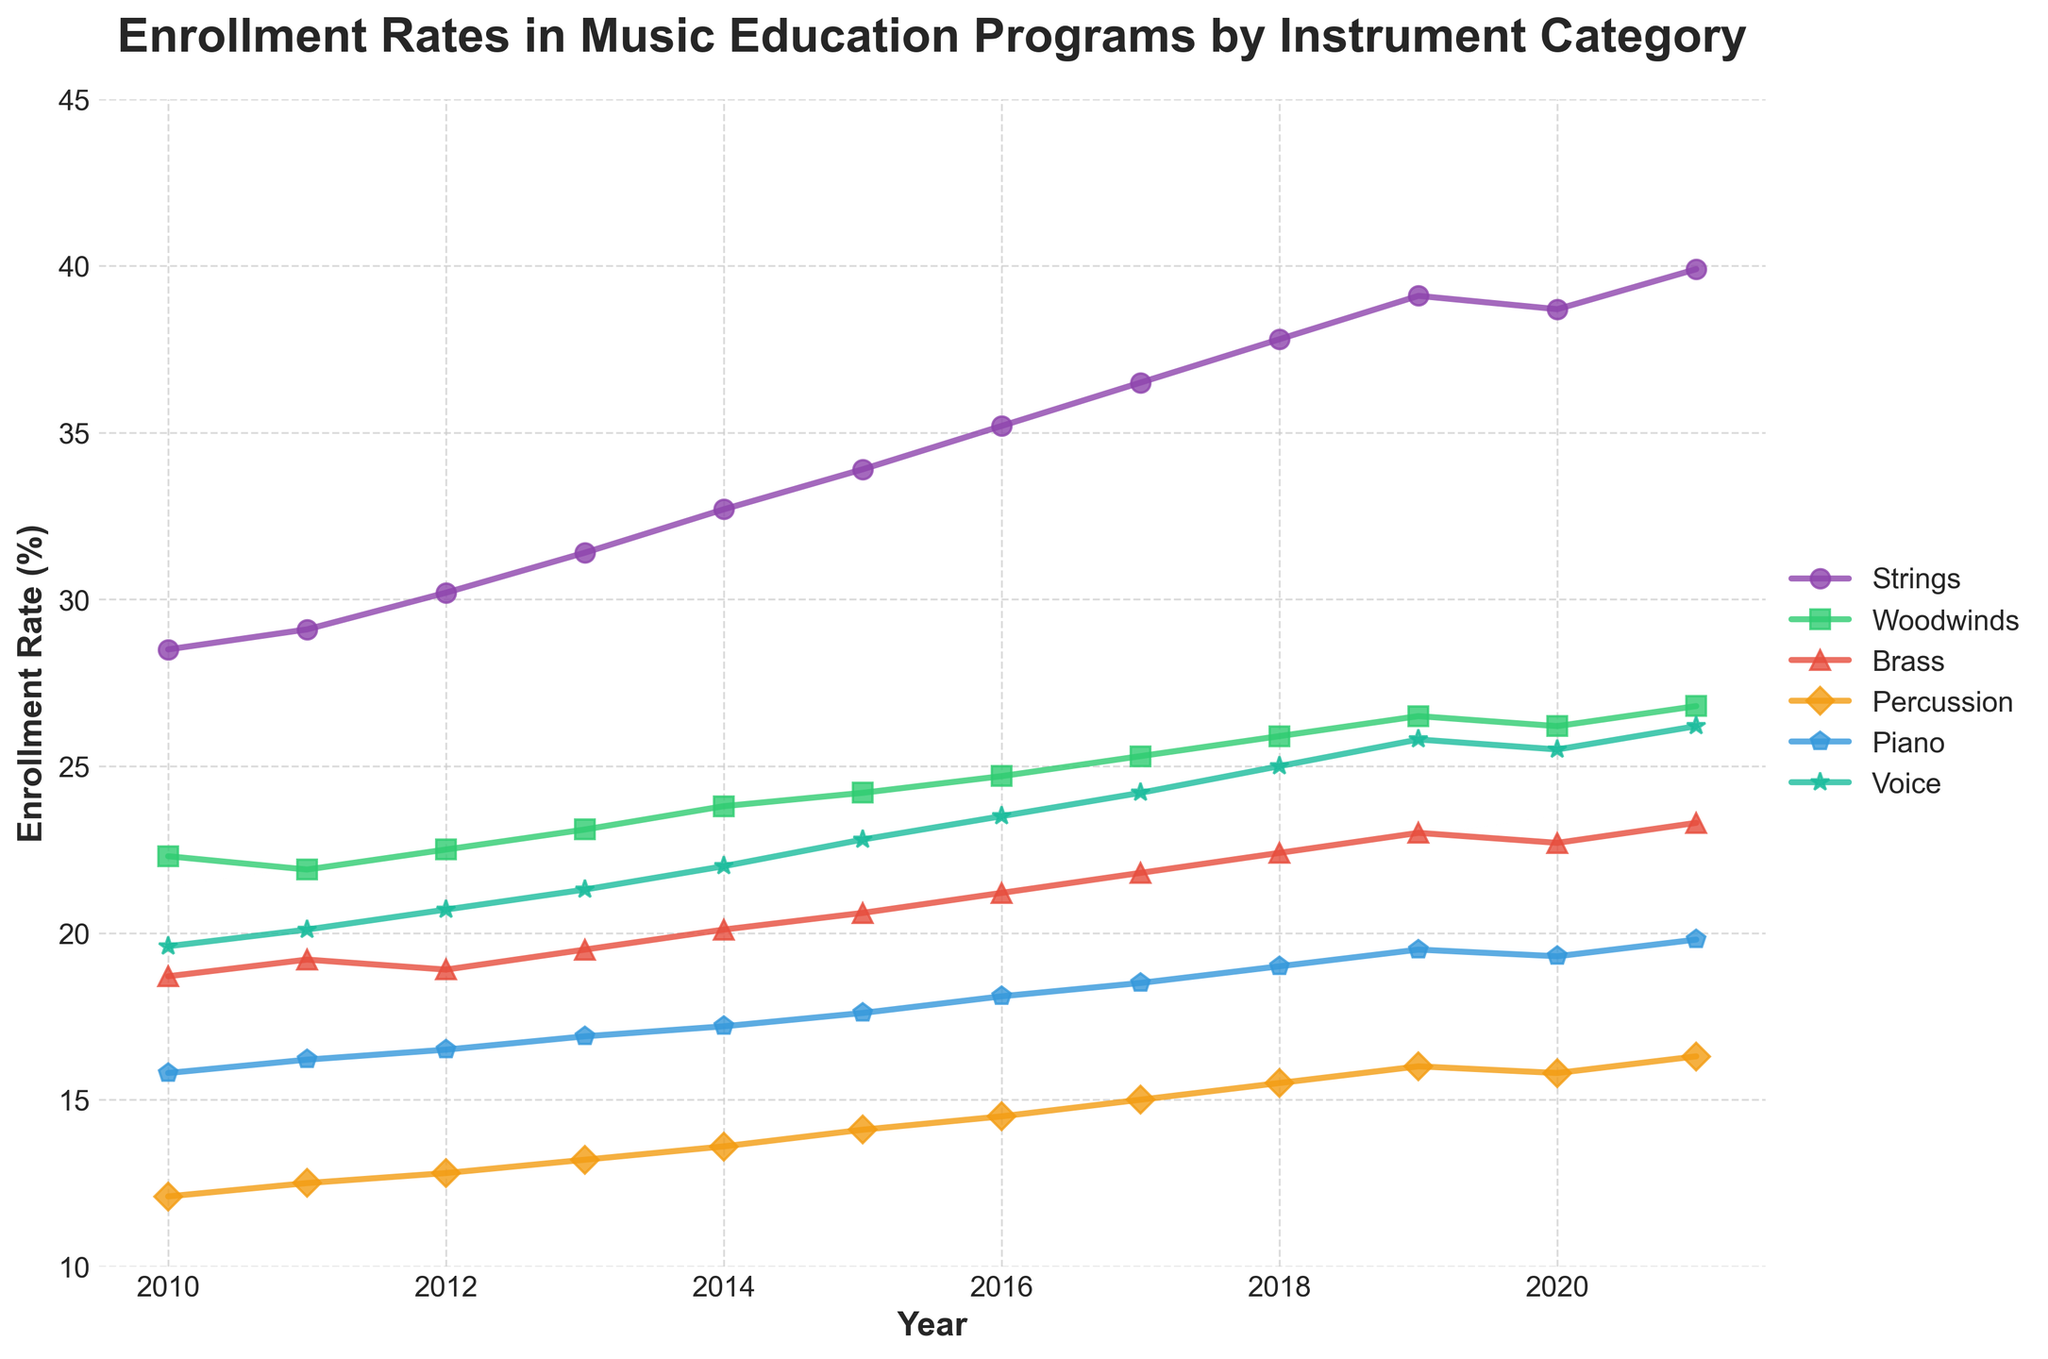Which instrument category showed the highest enrollment rates in 2021? Observe the endpoint of each line for the year 2021 and identify which line is positioned highest: Strings at 39.9%.
Answer: Strings How did enrollment rates for Brass and Woodwinds differ in 2015? Locate the year 2015 on the x-axis and compare the y-axis values for Brass (20.6%) and Woodwinds (24.2%). Brass is lower.
Answer: Woodwinds are higher What's the average enrollment rate for Voice from 2010 to 2021? Sum enrollment rates for Voice from each year and divide by the number of years: (19.6 + 20.1 + 20.7 + 21.3 + 22.0 + 22.8 + 23.5 + 24.2 + 25.0 + 25.8 + 25.5 + 26.2) / 12 = 22.95%.
Answer: 22.95% Which category had the smallest growth in enrollment from 2010 to 2020? Calculate the difference in enrollment rates between 2020 and 2010 for each category: Strings (+10.2%), Woodwinds (+3.9%), Brass (+4.0%), Percussion (+3.7%), Piano (+3.5%), Voice (+5.9%). Piano showed the smallest growth at +3.5%.
Answer: Piano Which year displayed a peak for Strings category enrollment rates? Notice the highest point in the Strings line occurs at 2021 with an enrollment rate of 39.9%.
Answer: 2021 Compare the enrollment trend for Strings and Piano between 2010 and 2021. Analyze both lines: Strings progressively increase from 28.5% to 39.9%, while Piano also shows a steady increase from 15.8% to 19.8%. Strings grew more substantially.
Answer: Strings grew more In 2016, which instrument category had lower enrollment rates, Percussion or Brass? Locate 2016 and compare the y-axis values for Percussion (14.5%) and Brass (21.2%): Percussion is lower.
Answer: Percussion What is the sum of enrollment rates for all categories in the year 2014? Add the enrollment rates for all categories in 2014: 32.7 (Strings) + 23.8 (Woodwinds) + 20.1 (Brass) + 13.6 (Percussion) + 17.2 (Piano) + 22.0 (Voice) = 129.4%.
Answer: 129.4% Which instrument category showed the most significant decline in enrollment rates from 2019 to 2020? Compare the enrollment rates for each category between 2019 and 2020, and find the largest decrease: Strings decreased by 0.4%, Woodwinds by 0.3%, Brass by 0.3%, Percussion by 0.2%, Piano by 0.2%, Voice by 0.3%. Strings show the most significant decline at 0.4%.
Answer: Strings 